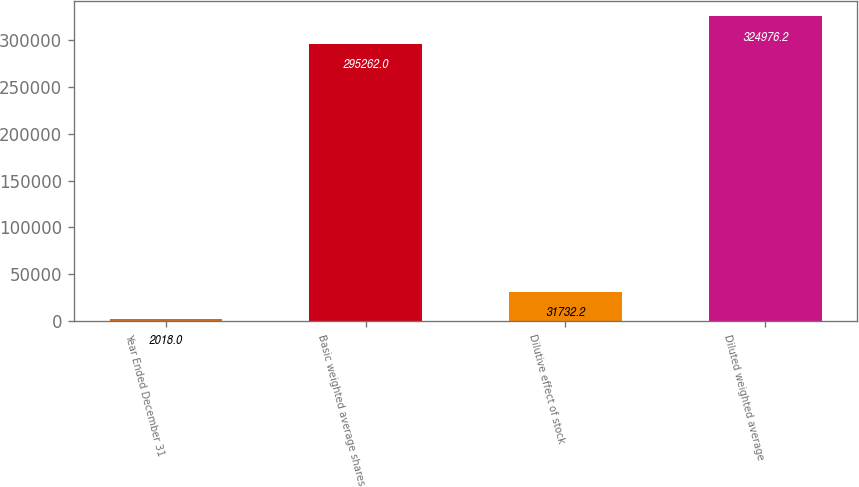Convert chart to OTSL. <chart><loc_0><loc_0><loc_500><loc_500><bar_chart><fcel>Year Ended December 31<fcel>Basic weighted average shares<fcel>Dilutive effect of stock<fcel>Diluted weighted average<nl><fcel>2018<fcel>295262<fcel>31732.2<fcel>324976<nl></chart> 